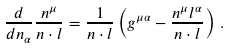<formula> <loc_0><loc_0><loc_500><loc_500>\frac { d } { d n _ { \alpha } } \frac { n ^ { \mu } } { n \cdot l } = \frac { 1 } { n \cdot l } \left ( g ^ { \mu \alpha } - \frac { n ^ { \mu } l ^ { \alpha } } { n \cdot l } \right ) \, .</formula> 